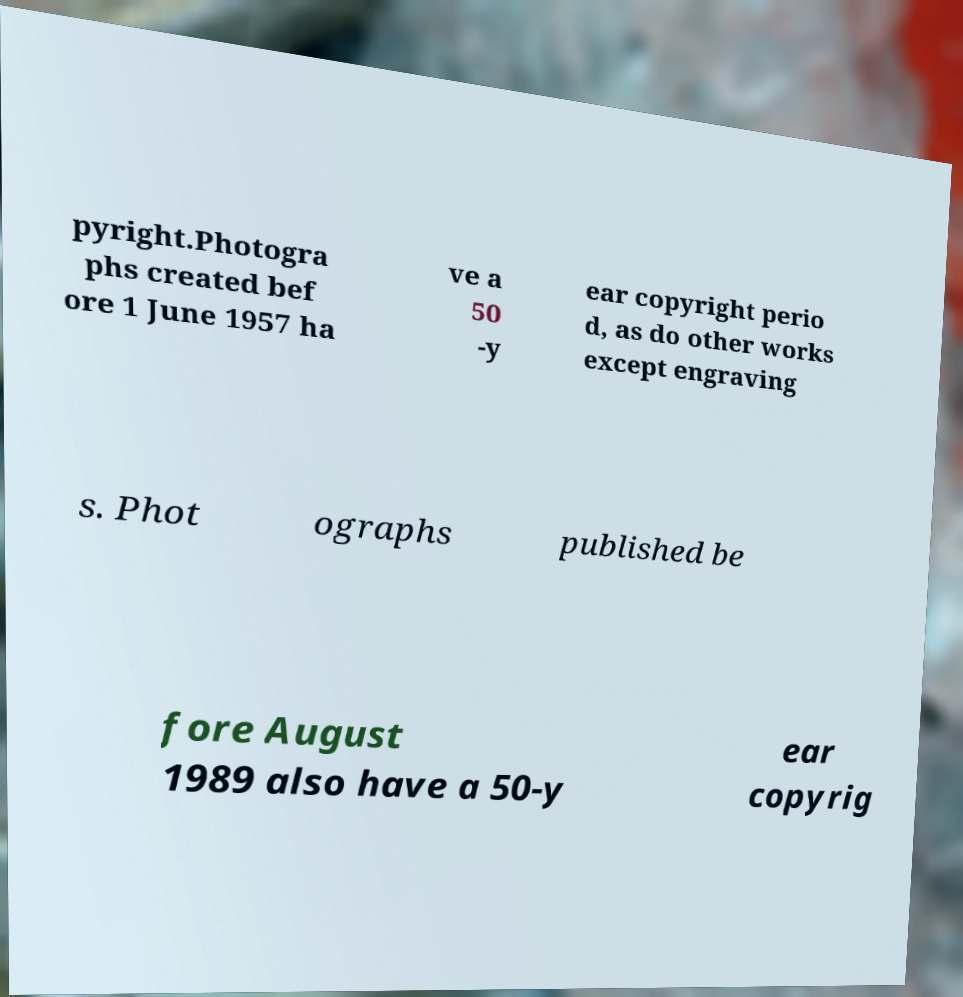Could you extract and type out the text from this image? pyright.Photogra phs created bef ore 1 June 1957 ha ve a 50 -y ear copyright perio d, as do other works except engraving s. Phot ographs published be fore August 1989 also have a 50-y ear copyrig 